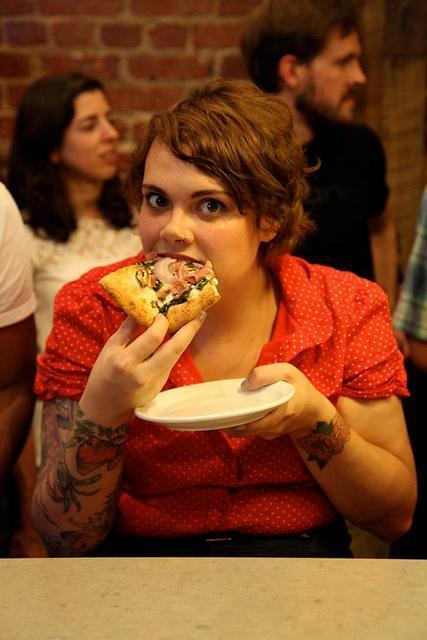How many pizzas are there?
Give a very brief answer. 1. How many people are visible?
Give a very brief answer. 4. How many cars are along side the bus?
Give a very brief answer. 0. 